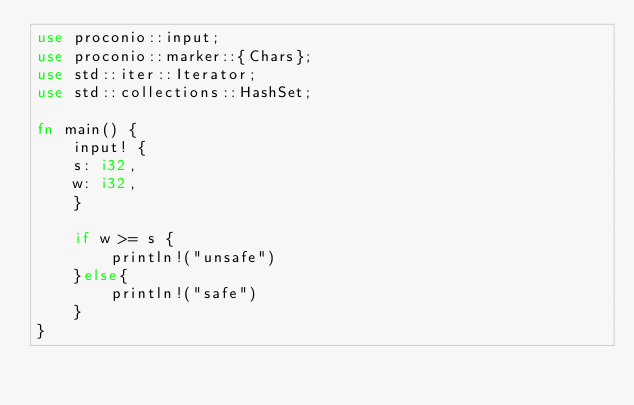<code> <loc_0><loc_0><loc_500><loc_500><_Rust_>use proconio::input;
use proconio::marker::{Chars};
use std::iter::Iterator;
use std::collections::HashSet;

fn main() {
    input! {
    s: i32,
    w: i32,
    }

    if w >= s {
        println!("unsafe")
    }else{
        println!("safe")
    }
}
</code> 